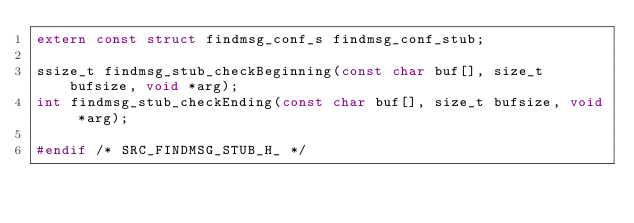<code> <loc_0><loc_0><loc_500><loc_500><_C_>extern const struct findmsg_conf_s findmsg_conf_stub;

ssize_t findmsg_stub_checkBeginning(const char buf[], size_t bufsize, void *arg);
int findmsg_stub_checkEnding(const char buf[], size_t bufsize, void *arg);

#endif /* SRC_FINDMSG_STUB_H_ */
</code> 